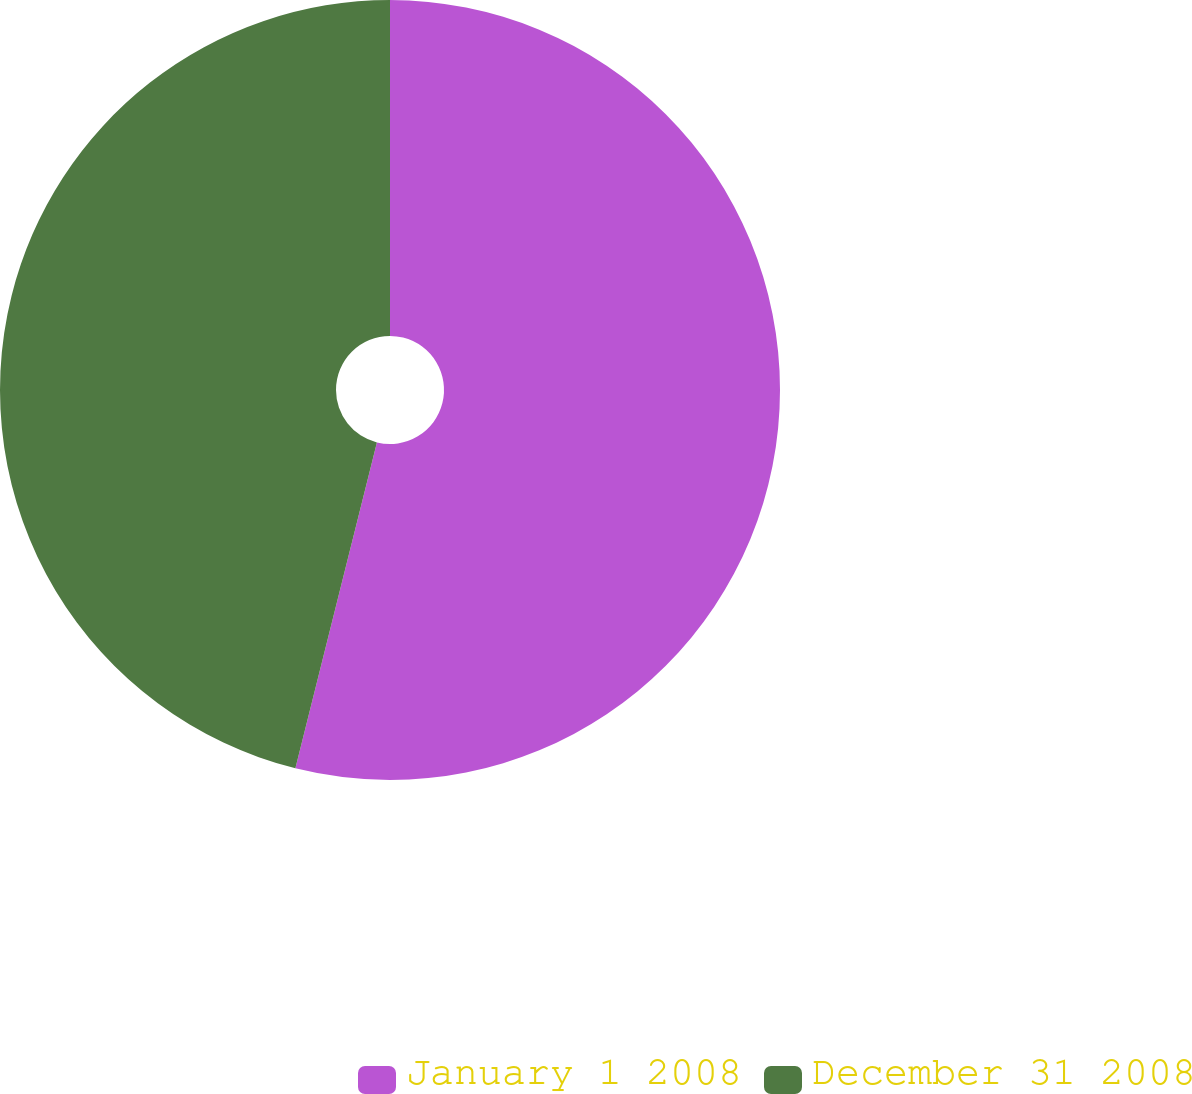Convert chart. <chart><loc_0><loc_0><loc_500><loc_500><pie_chart><fcel>January 1 2008<fcel>December 31 2008<nl><fcel>53.9%<fcel>46.1%<nl></chart> 